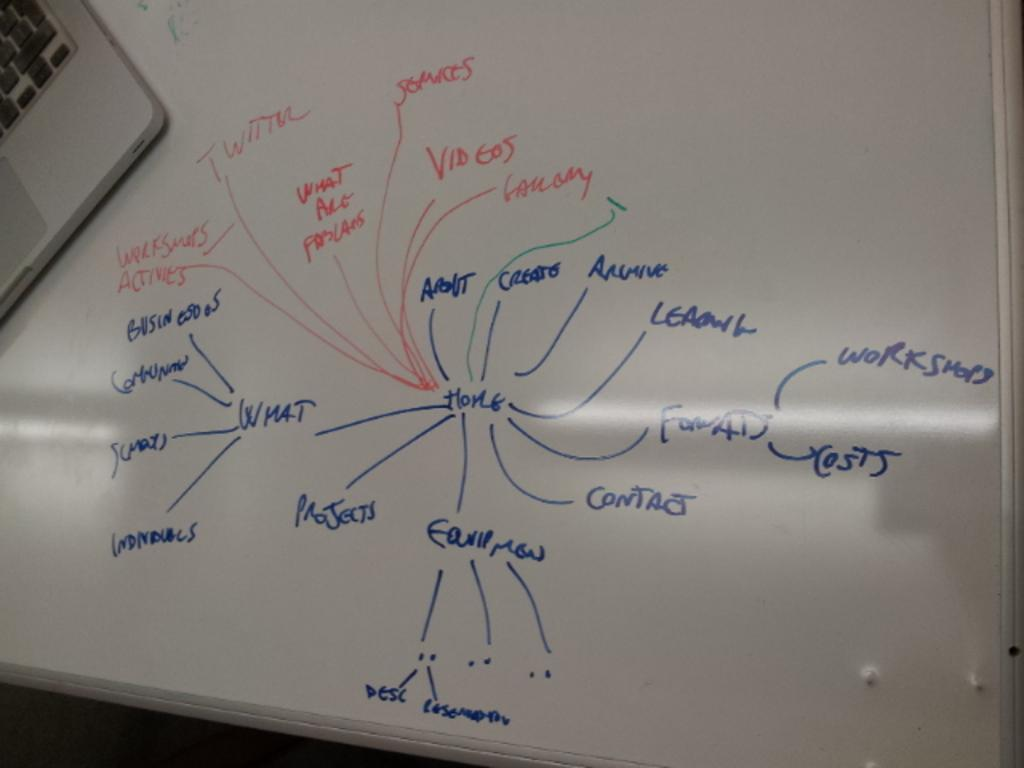<image>
Provide a brief description of the given image. A whiteboard contains diagrams containing terms such as projects, contact, costs and workshops. 